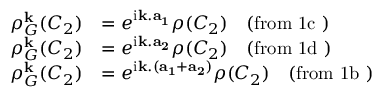Convert formula to latex. <formula><loc_0><loc_0><loc_500><loc_500>\begin{array} { r l } { \rho _ { G } ^ { k } ( C _ { 2 } ) } & { = e ^ { i { k . a _ { 1 } } } \rho ( C _ { 2 } ) \quad ( f r o m 1 c ) } \\ { \rho _ { G } ^ { k } ( C _ { 2 } ) } & { = e ^ { i { k . a _ { 2 } } } \rho ( C _ { 2 } ) \quad ( f r o m 1 d ) } \\ { \rho _ { G } ^ { k } ( C _ { 2 } ) } & { = e ^ { i { k . ( a _ { 1 } + a _ { 2 } ) } } \rho ( C _ { 2 } ) \quad ( f r o m 1 b ) } \end{array}</formula> 